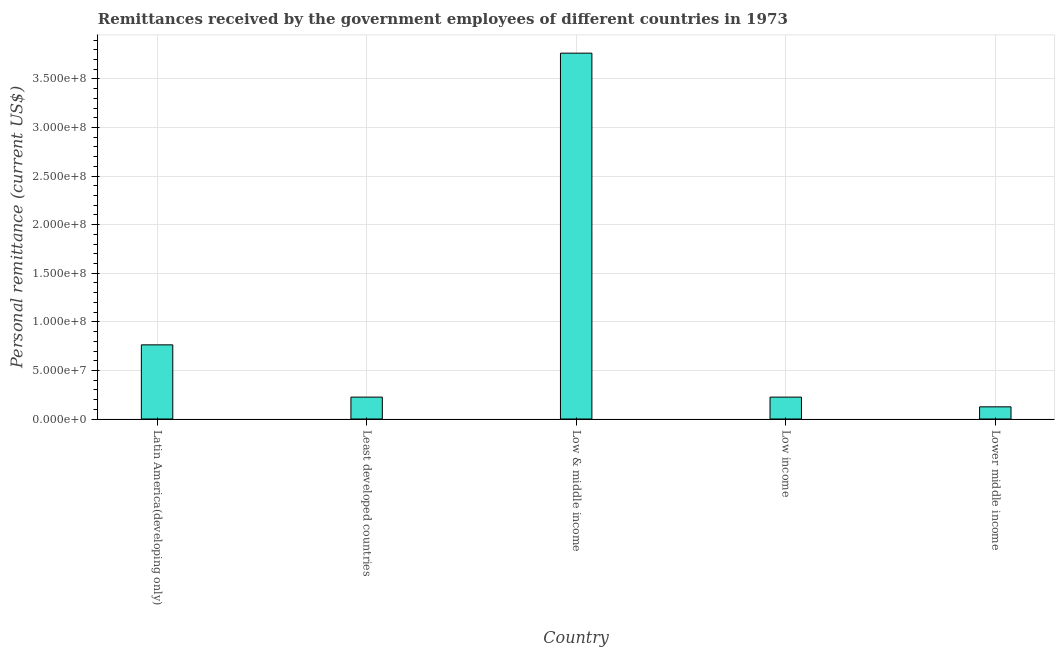What is the title of the graph?
Make the answer very short. Remittances received by the government employees of different countries in 1973. What is the label or title of the Y-axis?
Your answer should be compact. Personal remittance (current US$). What is the personal remittances in Lower middle income?
Your answer should be very brief. 1.25e+07. Across all countries, what is the maximum personal remittances?
Keep it short and to the point. 3.77e+08. Across all countries, what is the minimum personal remittances?
Your answer should be very brief. 1.25e+07. In which country was the personal remittances minimum?
Provide a short and direct response. Lower middle income. What is the sum of the personal remittances?
Give a very brief answer. 5.11e+08. What is the difference between the personal remittances in Least developed countries and Lower middle income?
Make the answer very short. 1.00e+07. What is the average personal remittances per country?
Make the answer very short. 1.02e+08. What is the median personal remittances?
Provide a short and direct response. 2.25e+07. In how many countries, is the personal remittances greater than 20000000 US$?
Provide a short and direct response. 4. What is the ratio of the personal remittances in Latin America(developing only) to that in Least developed countries?
Provide a succinct answer. 3.39. Is the personal remittances in Latin America(developing only) less than that in Low & middle income?
Offer a terse response. Yes. What is the difference between the highest and the second highest personal remittances?
Give a very brief answer. 3.00e+08. What is the difference between the highest and the lowest personal remittances?
Ensure brevity in your answer.  3.64e+08. In how many countries, is the personal remittances greater than the average personal remittances taken over all countries?
Ensure brevity in your answer.  1. Are all the bars in the graph horizontal?
Your answer should be compact. No. What is the Personal remittance (current US$) in Latin America(developing only)?
Provide a short and direct response. 7.63e+07. What is the Personal remittance (current US$) in Least developed countries?
Ensure brevity in your answer.  2.25e+07. What is the Personal remittance (current US$) in Low & middle income?
Your answer should be very brief. 3.77e+08. What is the Personal remittance (current US$) in Low income?
Keep it short and to the point. 2.25e+07. What is the Personal remittance (current US$) in Lower middle income?
Ensure brevity in your answer.  1.25e+07. What is the difference between the Personal remittance (current US$) in Latin America(developing only) and Least developed countries?
Offer a terse response. 5.38e+07. What is the difference between the Personal remittance (current US$) in Latin America(developing only) and Low & middle income?
Make the answer very short. -3.00e+08. What is the difference between the Personal remittance (current US$) in Latin America(developing only) and Low income?
Give a very brief answer. 5.38e+07. What is the difference between the Personal remittance (current US$) in Latin America(developing only) and Lower middle income?
Keep it short and to the point. 6.38e+07. What is the difference between the Personal remittance (current US$) in Least developed countries and Low & middle income?
Your answer should be very brief. -3.54e+08. What is the difference between the Personal remittance (current US$) in Least developed countries and Low income?
Give a very brief answer. 0. What is the difference between the Personal remittance (current US$) in Least developed countries and Lower middle income?
Your answer should be compact. 1.00e+07. What is the difference between the Personal remittance (current US$) in Low & middle income and Low income?
Your answer should be compact. 3.54e+08. What is the difference between the Personal remittance (current US$) in Low & middle income and Lower middle income?
Provide a succinct answer. 3.64e+08. What is the difference between the Personal remittance (current US$) in Low income and Lower middle income?
Give a very brief answer. 1.00e+07. What is the ratio of the Personal remittance (current US$) in Latin America(developing only) to that in Least developed countries?
Provide a succinct answer. 3.39. What is the ratio of the Personal remittance (current US$) in Latin America(developing only) to that in Low & middle income?
Your answer should be very brief. 0.2. What is the ratio of the Personal remittance (current US$) in Latin America(developing only) to that in Low income?
Your response must be concise. 3.39. What is the ratio of the Personal remittance (current US$) in Latin America(developing only) to that in Lower middle income?
Make the answer very short. 6.09. What is the ratio of the Personal remittance (current US$) in Least developed countries to that in Low & middle income?
Your answer should be very brief. 0.06. What is the ratio of the Personal remittance (current US$) in Least developed countries to that in Low income?
Offer a very short reply. 1. What is the ratio of the Personal remittance (current US$) in Least developed countries to that in Lower middle income?
Make the answer very short. 1.8. What is the ratio of the Personal remittance (current US$) in Low & middle income to that in Low income?
Your answer should be very brief. 16.71. What is the ratio of the Personal remittance (current US$) in Low & middle income to that in Lower middle income?
Your response must be concise. 30.03. What is the ratio of the Personal remittance (current US$) in Low income to that in Lower middle income?
Offer a terse response. 1.8. 